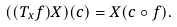Convert formula to latex. <formula><loc_0><loc_0><loc_500><loc_500>( ( T _ { x } f ) X ) ( c ) = X ( c \circ f ) .</formula> 